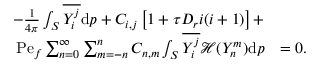Convert formula to latex. <formula><loc_0><loc_0><loc_500><loc_500>\begin{array} { r l } { - \frac { 1 } { 4 \pi } \int _ { S } \overline { { Y _ { i } ^ { j } } } d p + C _ { i , j } \left [ 1 + \tau D _ { r } i ( i + 1 ) \right ] + } \\ { P e _ { f } \sum _ { n = 0 } ^ { \infty } \sum _ { m = - n } ^ { n } C _ { n , m } \int _ { S } \overline { { Y _ { i } ^ { j } } } \mathcal { H } ( Y _ { n } ^ { m } ) d p } & { = 0 . } \end{array}</formula> 